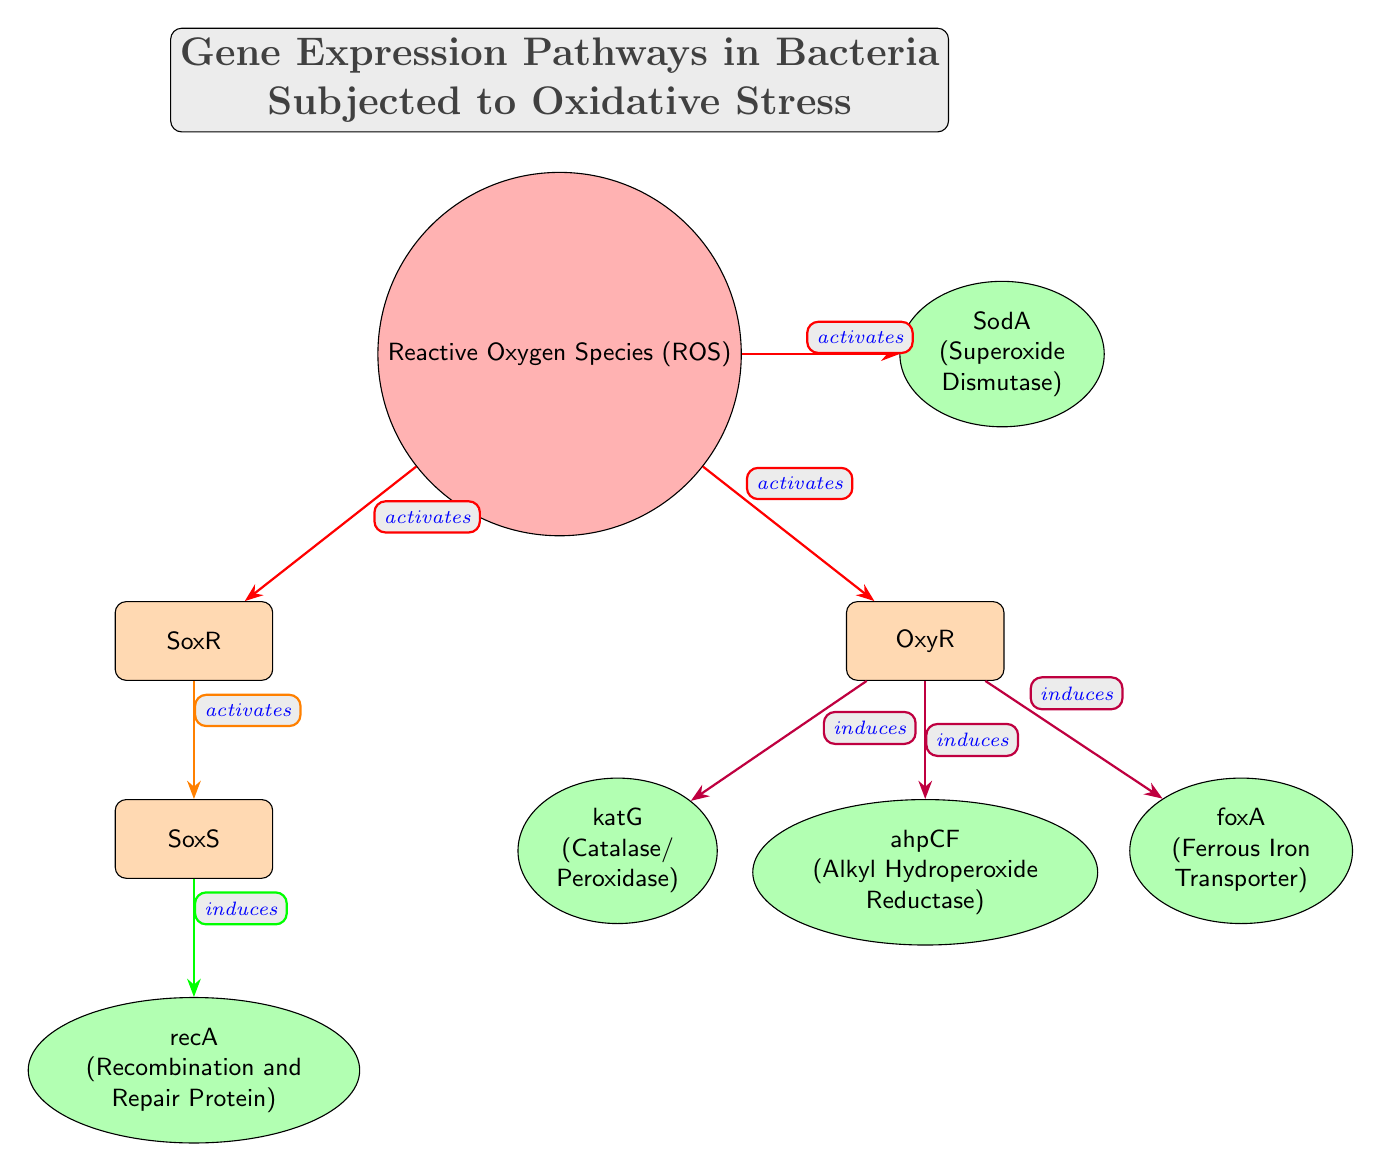What is the main regulatory factor responding to Reactive Oxygen Species? In the diagram, the arrow leading from Reactive Oxygen Species (ROS) to SoxR indicates that SoxR is the first regulator activated by ROS. Thus, we identify SoxR as the main regulatory factor.
Answer: SoxR How many genes are induced by OxyR? By examining the diagram, we see that there are three arrows leading out from OxyR towards three nodes: katG, ahpCF, and foxA. Therefore, OxyR induces a total of three genes.
Answer: 3 Which gene is associated with Superoxide Dismutase? In the diagram, SodA is labeled as producing Superoxide Dismutase. It is positioned directly to the right of the ROS node, with an activation edge coming from ROS.
Answer: SodA What color represents the genes in the diagram? The genes in the diagram are represented by the color green, as indicated by the fill style assigned to gene nodes in the TikZ code.
Answer: Green Which protein is responsible for recombination and repair? The recA gene is connected to SoxS in the diagram and is explicitly labeled as the "Recombination and Repair Protein," making it the protein responsible for these functions.
Answer: recA What is the relationship between SoxR and SoxS? The diagram shows a directed edge from SoxR to SoxS labeled "activates." This indicates that SoxR activates SoxS, establishing a regulatory relationship between the two.
Answer: activates Which factors are activated by Reactive Oxygen Species? The diagram indicates that ROS activates SoxR, OxyR, and SodA by following the edges leading from the ROS node. Thus, the factors activated by ROS are SoxR, OxyR, and SodA.
Answer: SoxR, OxyR, SodA What type of stress is shown in the diagram? The title of the diagram clearly mentions "Oxidative Stress," which is further emphasized through the involvement of Reactive Oxygen Species (ROS) as a node in the pathway.
Answer: Oxidative Stress 